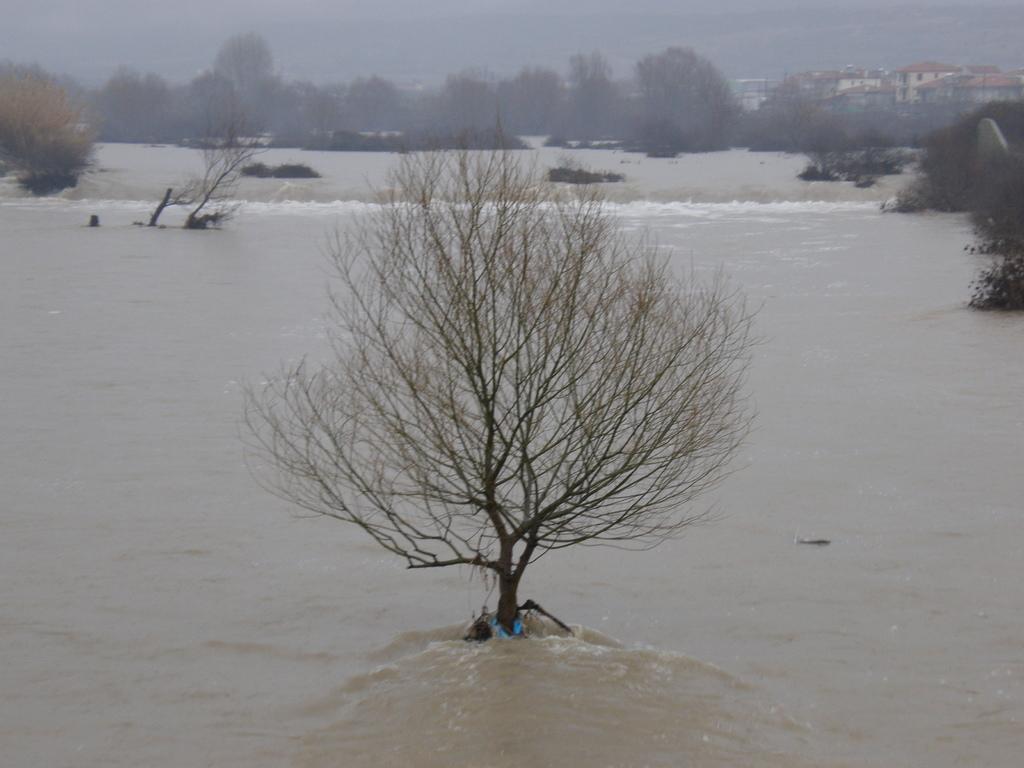Could you give a brief overview of what you see in this image? In this picture we can see water and trees. Far there are houses. 